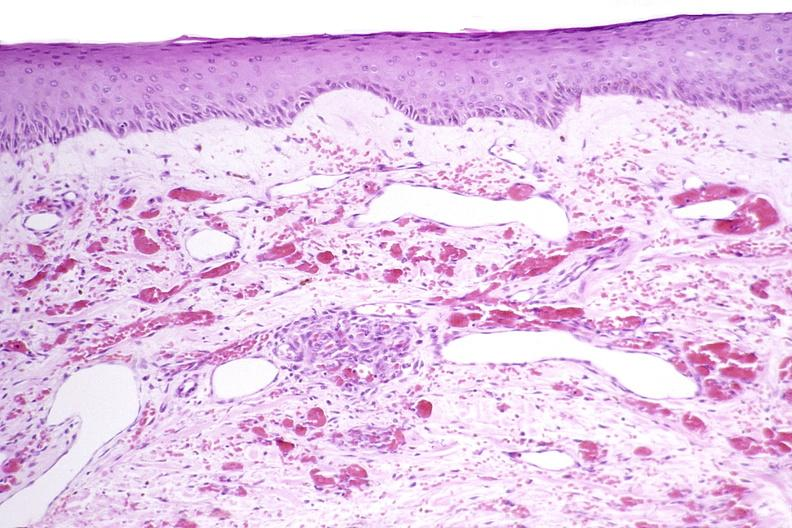does this image show skin, kaposis 's sarcoma?
Answer the question using a single word or phrase. Yes 